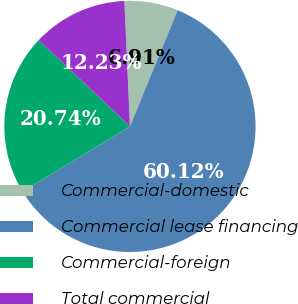Convert chart to OTSL. <chart><loc_0><loc_0><loc_500><loc_500><pie_chart><fcel>Commercial-domestic<fcel>Commercial lease financing<fcel>Commercial-foreign<fcel>Total commercial<nl><fcel>6.91%<fcel>60.11%<fcel>20.74%<fcel>12.23%<nl></chart> 